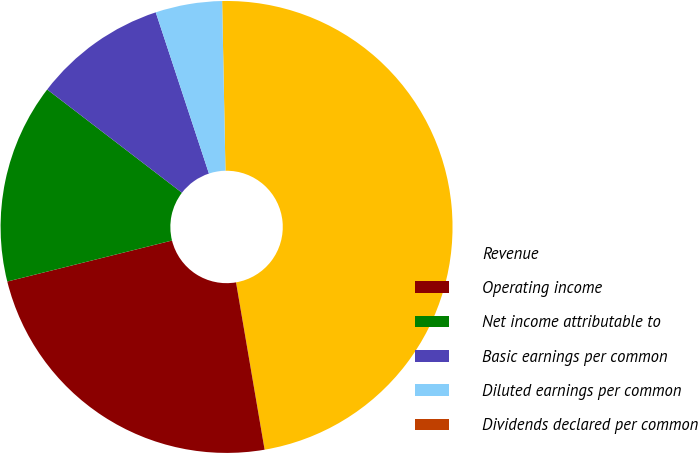Convert chart. <chart><loc_0><loc_0><loc_500><loc_500><pie_chart><fcel>Revenue<fcel>Operating income<fcel>Net income attributable to<fcel>Basic earnings per common<fcel>Diluted earnings per common<fcel>Dividends declared per common<nl><fcel>47.62%<fcel>23.81%<fcel>14.29%<fcel>9.52%<fcel>4.76%<fcel>0.0%<nl></chart> 